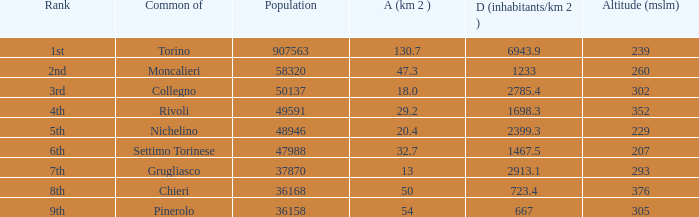The common of Chieri has what population density? 723.4. 